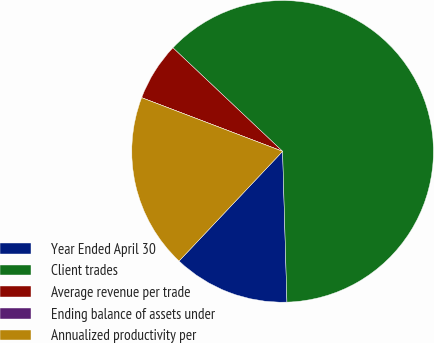Convert chart to OTSL. <chart><loc_0><loc_0><loc_500><loc_500><pie_chart><fcel>Year Ended April 30<fcel>Client trades<fcel>Average revenue per trade<fcel>Ending balance of assets under<fcel>Annualized productivity per<nl><fcel>12.5%<fcel>62.5%<fcel>6.25%<fcel>0.0%<fcel>18.75%<nl></chart> 